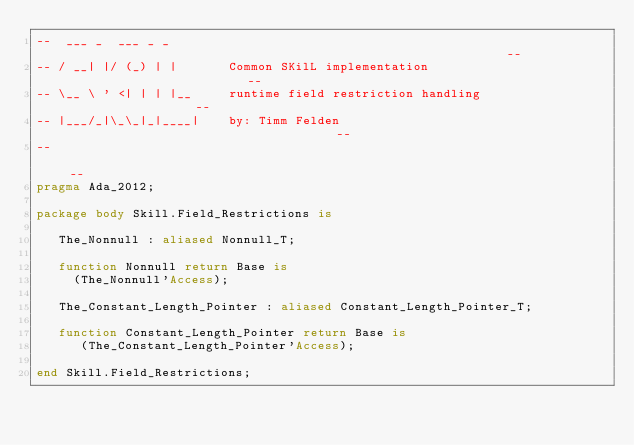<code> <loc_0><loc_0><loc_500><loc_500><_Ada_>--  ___ _  ___ _ _                                                            --
-- / __| |/ (_) | |       Common SKilL implementation                         --
-- \__ \ ' <| | | |__     runtime field restriction handling                  --
-- |___/_|\_\_|_|____|    by: Timm Felden                                     --
--                                                                            --
pragma Ada_2012;

package body Skill.Field_Restrictions is

   The_Nonnull : aliased Nonnull_T;

   function Nonnull return Base is
     (The_Nonnull'Access);

   The_Constant_Length_Pointer : aliased Constant_Length_Pointer_T;

   function Constant_Length_Pointer return Base is
      (The_Constant_Length_Pointer'Access);

end Skill.Field_Restrictions;
</code> 